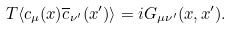Convert formula to latex. <formula><loc_0><loc_0><loc_500><loc_500>T \langle c _ { \mu } ( x ) \overline { c } _ { \nu ^ { \prime } } ( x ^ { \prime } ) \rangle = i G _ { \mu \nu ^ { \prime } } ( x , x ^ { \prime } ) .</formula> 